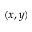<formula> <loc_0><loc_0><loc_500><loc_500>( x , y )</formula> 